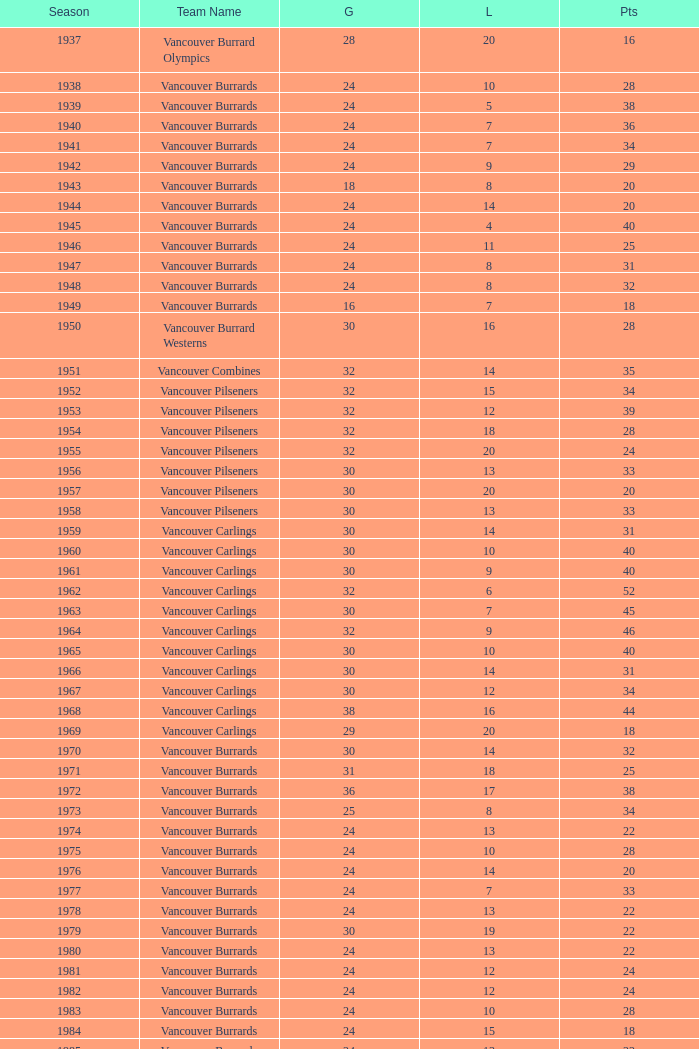What's the lowest number of points with fewer than 8 losses and fewer than 24 games for the vancouver burrards? 18.0. 